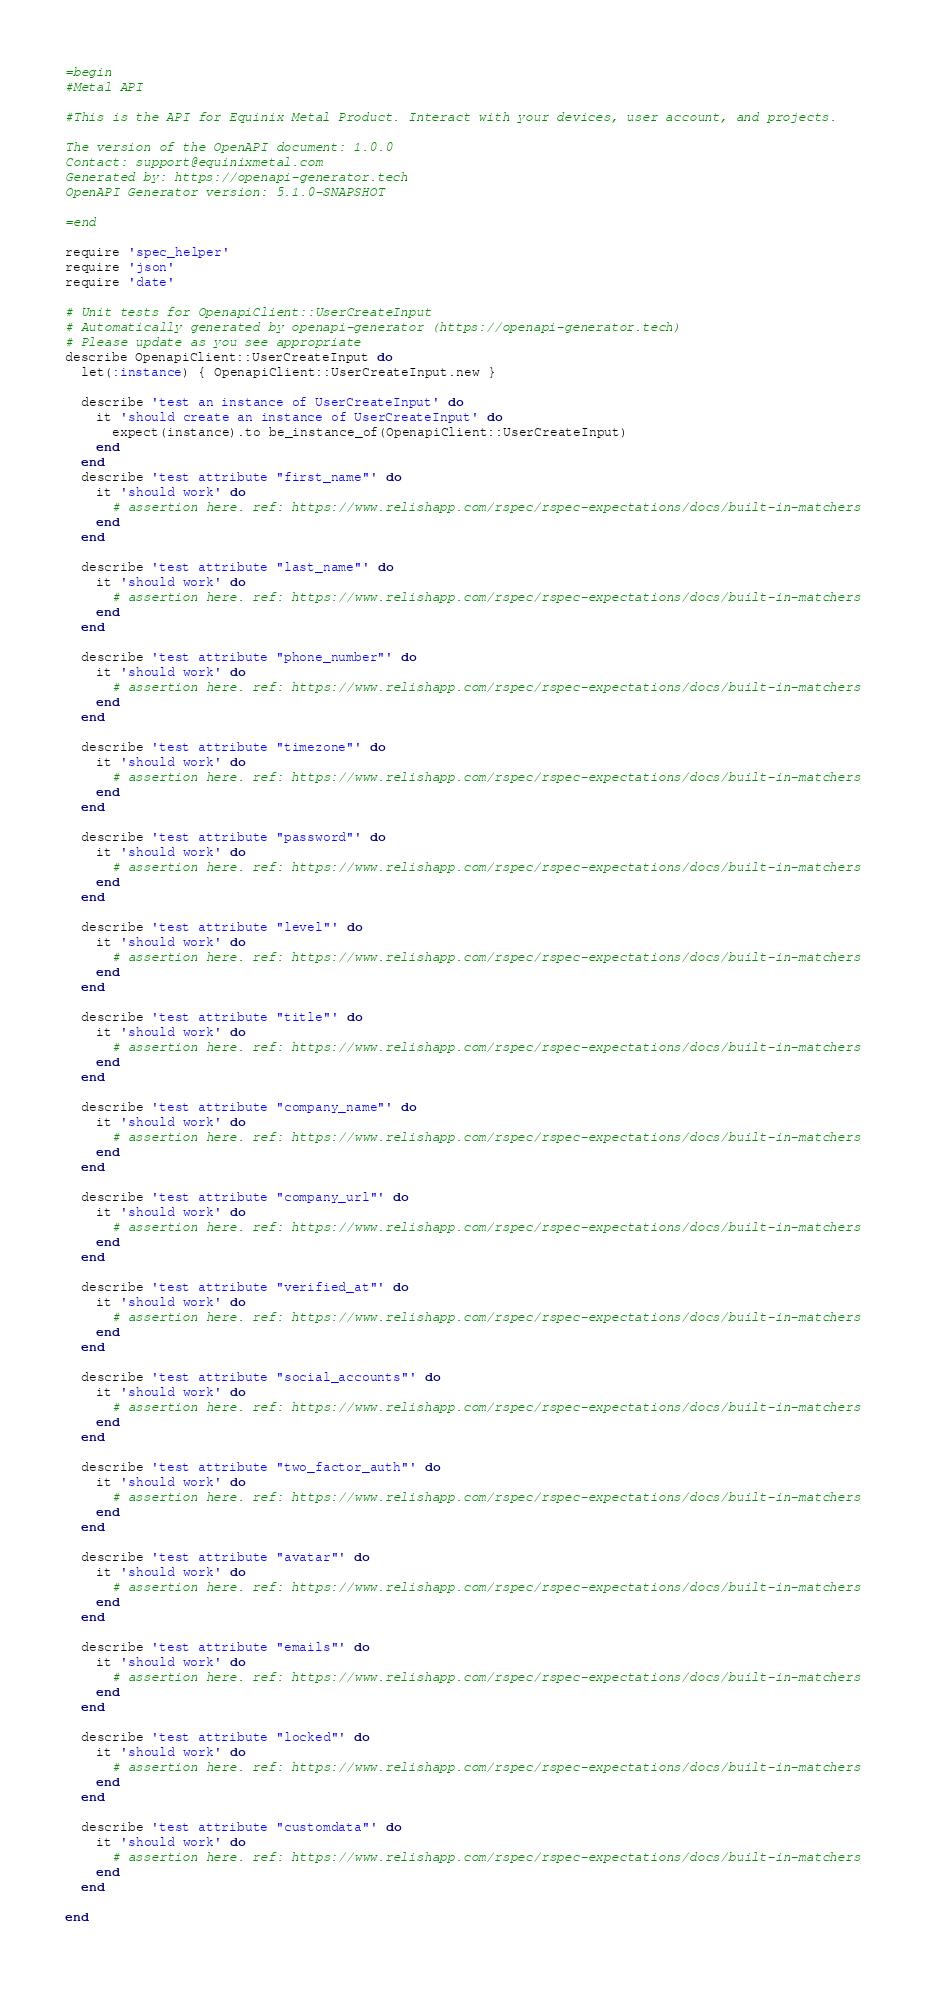Convert code to text. <code><loc_0><loc_0><loc_500><loc_500><_Ruby_>=begin
#Metal API

#This is the API for Equinix Metal Product. Interact with your devices, user account, and projects.

The version of the OpenAPI document: 1.0.0
Contact: support@equinixmetal.com
Generated by: https://openapi-generator.tech
OpenAPI Generator version: 5.1.0-SNAPSHOT

=end

require 'spec_helper'
require 'json'
require 'date'

# Unit tests for OpenapiClient::UserCreateInput
# Automatically generated by openapi-generator (https://openapi-generator.tech)
# Please update as you see appropriate
describe OpenapiClient::UserCreateInput do
  let(:instance) { OpenapiClient::UserCreateInput.new }

  describe 'test an instance of UserCreateInput' do
    it 'should create an instance of UserCreateInput' do
      expect(instance).to be_instance_of(OpenapiClient::UserCreateInput)
    end
  end
  describe 'test attribute "first_name"' do
    it 'should work' do
      # assertion here. ref: https://www.relishapp.com/rspec/rspec-expectations/docs/built-in-matchers
    end
  end

  describe 'test attribute "last_name"' do
    it 'should work' do
      # assertion here. ref: https://www.relishapp.com/rspec/rspec-expectations/docs/built-in-matchers
    end
  end

  describe 'test attribute "phone_number"' do
    it 'should work' do
      # assertion here. ref: https://www.relishapp.com/rspec/rspec-expectations/docs/built-in-matchers
    end
  end

  describe 'test attribute "timezone"' do
    it 'should work' do
      # assertion here. ref: https://www.relishapp.com/rspec/rspec-expectations/docs/built-in-matchers
    end
  end

  describe 'test attribute "password"' do
    it 'should work' do
      # assertion here. ref: https://www.relishapp.com/rspec/rspec-expectations/docs/built-in-matchers
    end
  end

  describe 'test attribute "level"' do
    it 'should work' do
      # assertion here. ref: https://www.relishapp.com/rspec/rspec-expectations/docs/built-in-matchers
    end
  end

  describe 'test attribute "title"' do
    it 'should work' do
      # assertion here. ref: https://www.relishapp.com/rspec/rspec-expectations/docs/built-in-matchers
    end
  end

  describe 'test attribute "company_name"' do
    it 'should work' do
      # assertion here. ref: https://www.relishapp.com/rspec/rspec-expectations/docs/built-in-matchers
    end
  end

  describe 'test attribute "company_url"' do
    it 'should work' do
      # assertion here. ref: https://www.relishapp.com/rspec/rspec-expectations/docs/built-in-matchers
    end
  end

  describe 'test attribute "verified_at"' do
    it 'should work' do
      # assertion here. ref: https://www.relishapp.com/rspec/rspec-expectations/docs/built-in-matchers
    end
  end

  describe 'test attribute "social_accounts"' do
    it 'should work' do
      # assertion here. ref: https://www.relishapp.com/rspec/rspec-expectations/docs/built-in-matchers
    end
  end

  describe 'test attribute "two_factor_auth"' do
    it 'should work' do
      # assertion here. ref: https://www.relishapp.com/rspec/rspec-expectations/docs/built-in-matchers
    end
  end

  describe 'test attribute "avatar"' do
    it 'should work' do
      # assertion here. ref: https://www.relishapp.com/rspec/rspec-expectations/docs/built-in-matchers
    end
  end

  describe 'test attribute "emails"' do
    it 'should work' do
      # assertion here. ref: https://www.relishapp.com/rspec/rspec-expectations/docs/built-in-matchers
    end
  end

  describe 'test attribute "locked"' do
    it 'should work' do
      # assertion here. ref: https://www.relishapp.com/rspec/rspec-expectations/docs/built-in-matchers
    end
  end

  describe 'test attribute "customdata"' do
    it 'should work' do
      # assertion here. ref: https://www.relishapp.com/rspec/rspec-expectations/docs/built-in-matchers
    end
  end

end
</code> 